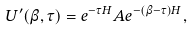<formula> <loc_0><loc_0><loc_500><loc_500>U ^ { \prime } ( \beta , \tau ) = e ^ { - \tau H } A e ^ { - ( \beta - \tau ) H } ,</formula> 